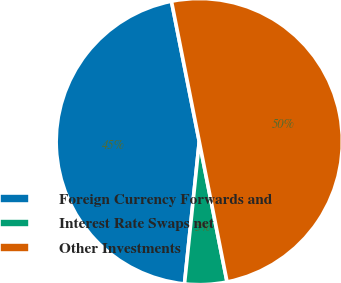Convert chart. <chart><loc_0><loc_0><loc_500><loc_500><pie_chart><fcel>Foreign Currency Forwards and<fcel>Interest Rate Swaps net<fcel>Other Investments<nl><fcel>45.24%<fcel>4.76%<fcel>50.0%<nl></chart> 